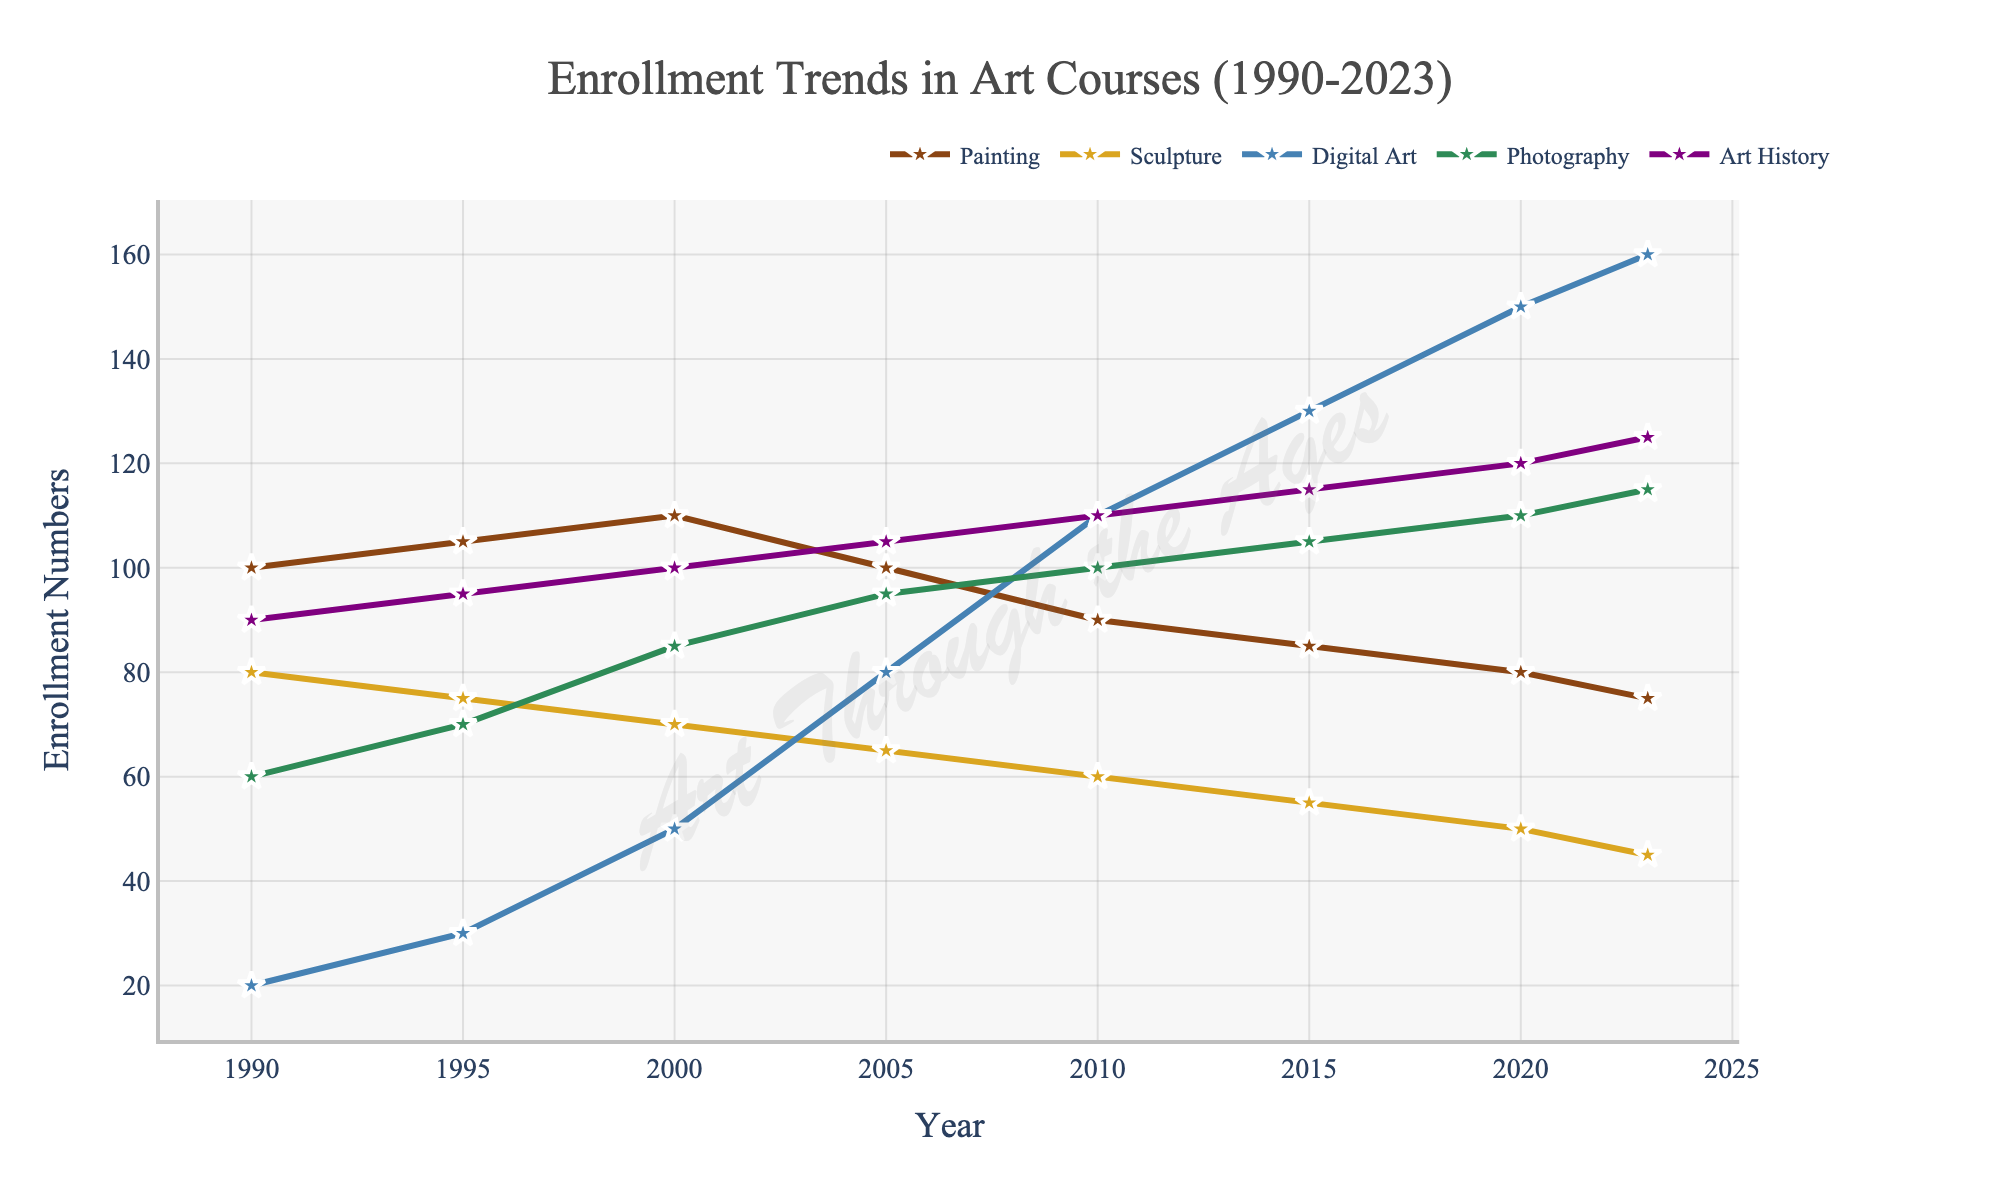What's the trend in enrollment numbers for Digital Art from 1990 to 2023? The Digital Art enrollment numbers start at 20 in 1990 and consistently increase over the years, peaking at 160 in 2023. This indicates a growing interest in Digital Art over the observed period.
Answer: A consistent increase What was the enrollment for Painting and Sculpture in 1990, and which had more students? In 1990, the enrollment for Painting was 100, and for Sculpture, it was 80. Painting had more students.
Answer: Painting Comparing the enrollment numbers in 2023, which course had the least and the most students? In 2023, Digital Art had the most students with 160 enrollments, and Sculpture had the least with 45 enrollments.
Answer: Digital Art; Sculpture How has the enrollment number for Photography changed between 1995 and 2020? Photography enrollment numbers increased from 70 in 1995 to 110 in 2020. This signifies a rising trend in the popularity of Photography courses.
Answer: Increased by 40 What is the average enrollment number for Art History from 1990 to 2023? The enrollment numbers for Art History from 1990 to 2023 are 90, 95, 100, 105, 110, 115, 120, and 125. The sum of these numbers is 860, so the average is 860/8 = 107.5.
Answer: 107.5 In which year did Painting see the largest drop in enrollment compared to the previous year? Painting saw the largest drop in enrollment between 2000 and 2005, where the numbers fell from 110 to 100, a decrease of 10 students.
Answer: 2000 to 2005 What's the combined total enrollment for all courses in the year 2023? The enrollments for 2023 are Painting: 75, Sculpture: 45, Digital Art: 160, Photography: 115, and Art History: 125. The combined total is 75 + 45 + 160 + 115 + 125 = 520.
Answer: 520 Which course had a more stable enrollment trend, Art History or Sculpture? Art History shows a consistent increase in enrollments from 90 in 1990 to 125 in 2023. Sculpture, on the other hand, shows a consistent decline from 80 in 1990 to 45 in 2023. Therefore, Art History had a more stable and positive trend.
Answer: Art History If you sum the enrollment numbers for Painting and Digital Art in 2015, what value do you get? In 2015, the enrollment for Painting was 85, and for Digital Art, it was 130. Their sum is 85 + 130 = 215.
Answer: 215 How does the enrollment for Sculpture in 2023 compare to its enrollment in 1990? Sculpture’s enrollment decreased from 80 in 1990 to 45 in 2023, showing a downward trend.
Answer: Decreased by 35 